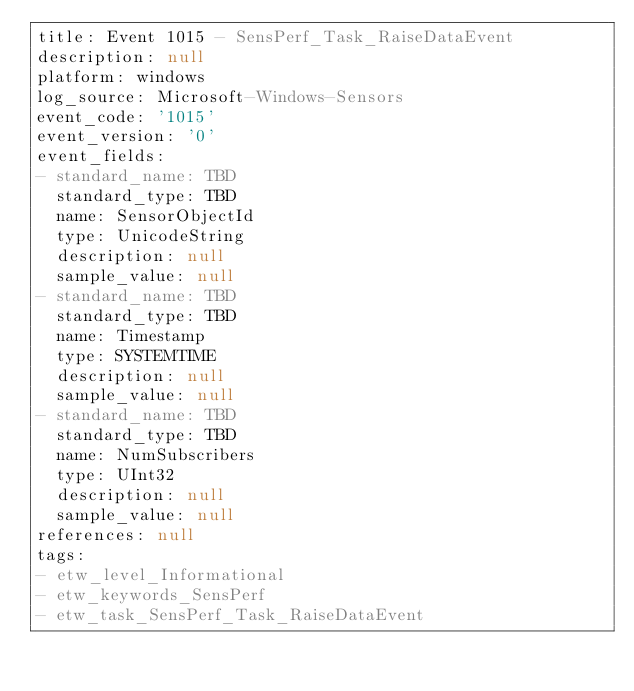Convert code to text. <code><loc_0><loc_0><loc_500><loc_500><_YAML_>title: Event 1015 - SensPerf_Task_RaiseDataEvent
description: null
platform: windows
log_source: Microsoft-Windows-Sensors
event_code: '1015'
event_version: '0'
event_fields:
- standard_name: TBD
  standard_type: TBD
  name: SensorObjectId
  type: UnicodeString
  description: null
  sample_value: null
- standard_name: TBD
  standard_type: TBD
  name: Timestamp
  type: SYSTEMTIME
  description: null
  sample_value: null
- standard_name: TBD
  standard_type: TBD
  name: NumSubscribers
  type: UInt32
  description: null
  sample_value: null
references: null
tags:
- etw_level_Informational
- etw_keywords_SensPerf
- etw_task_SensPerf_Task_RaiseDataEvent
</code> 